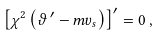<formula> <loc_0><loc_0><loc_500><loc_500>\left [ \chi ^ { 2 } \left ( \vartheta \, ^ { \prime } - m v _ { s } \right ) \right ] ^ { \prime } = 0 \, ,</formula> 